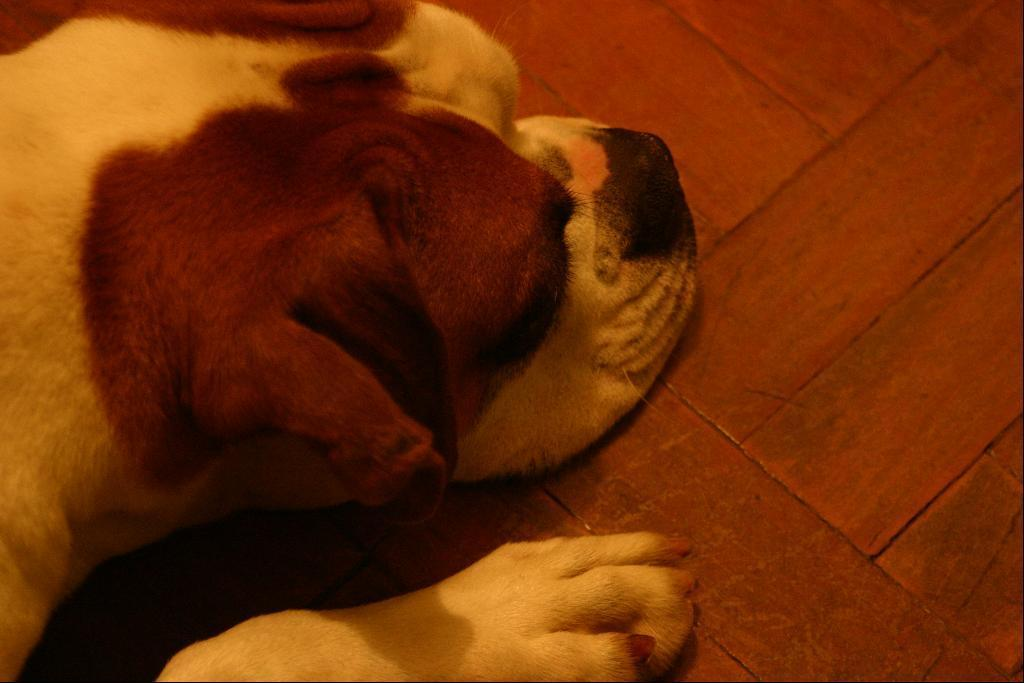What animal is present in the image? There is a dog in the image. What position is the dog in? The dog is laying on the floor. What type of cheese is the dog eating in the image? There is no cheese present in the image, and the dog is not eating anything. 